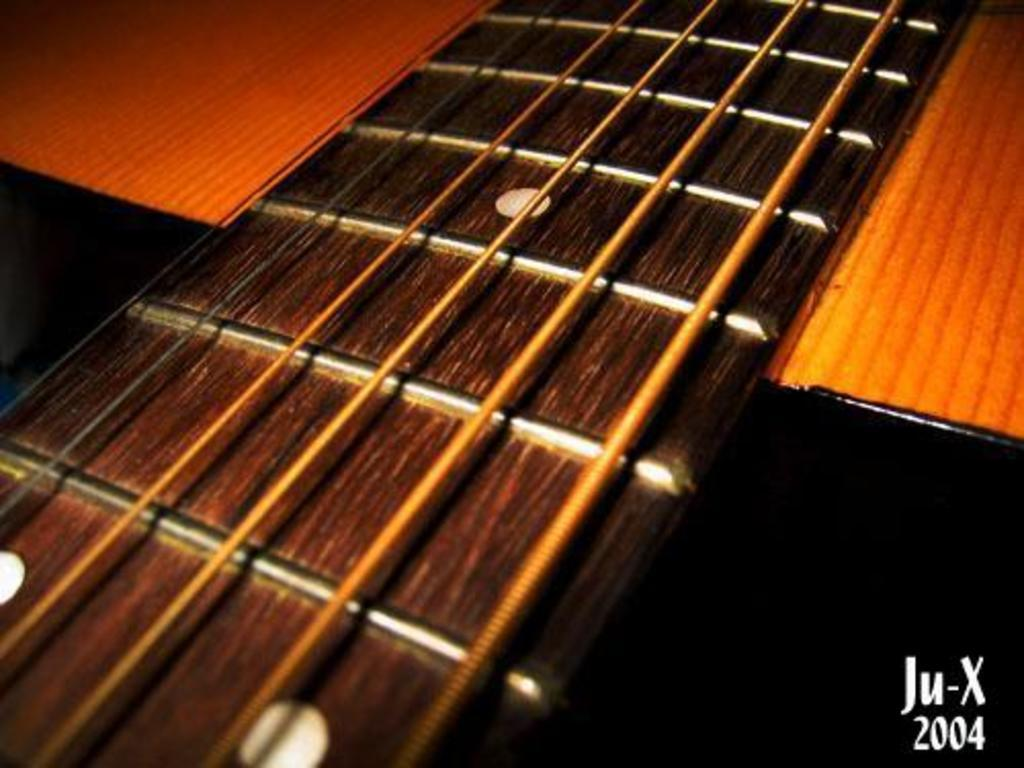What type of structure is present in the image? There is a wooden platform in the image. What can be seen on the wooden platform? The wooden platform has strings on it and round-shaped holes. What does the wooden platform resemble? The wooden platform and its features resemble a guitar. What is the level of friction between the wooden platform and the thing in the image? There is no "thing" mentioned in the image, and the level of friction cannot be determined without more information. 